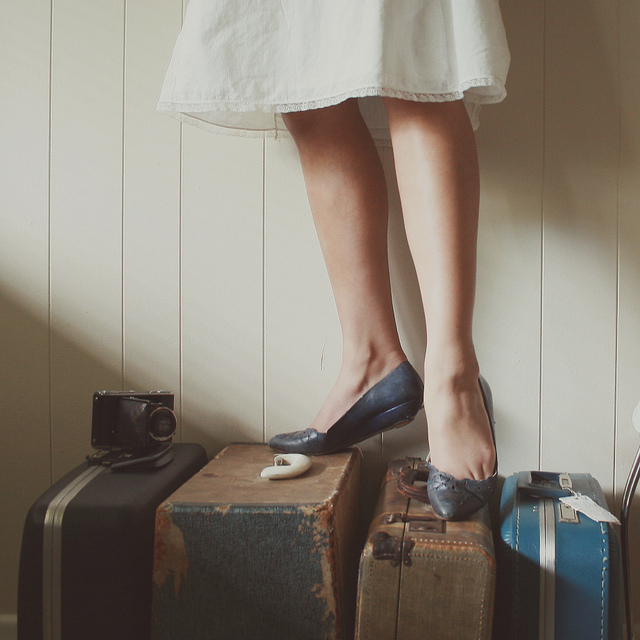What might be the story behind this collection of luggage? The luggage, adorned with travel stickers and displaying signs of wear, implies a history of extensive travel. They evoke a sense of wanderlust and could belong to someone who cherishes adventurous experiences and exploring new destinations. The vintage style of the suitcases also suggests these journeys may have taken place in a bygone era, or the owner appreciates the aesthetic of antique items as a form of escapism or nostalgia. 